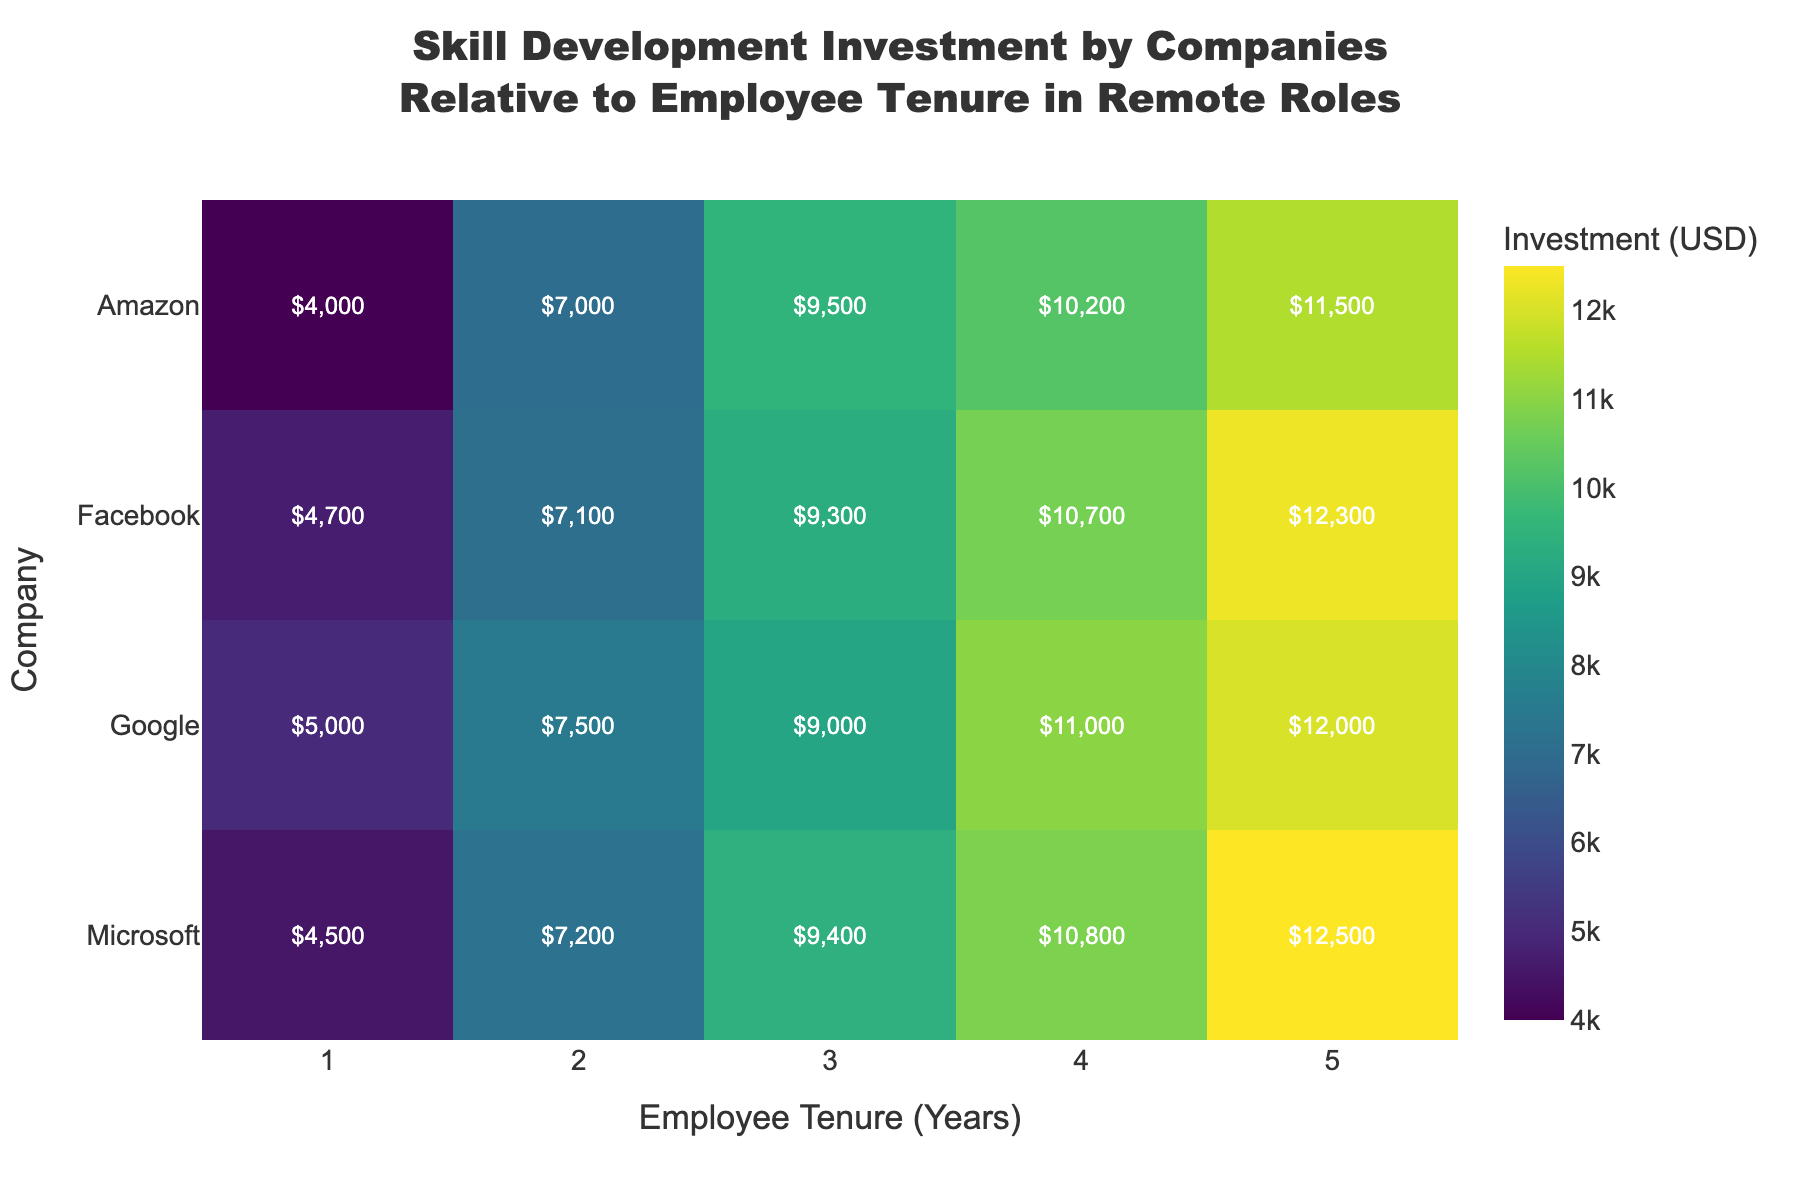What is the title of the heatmap? The title is displayed at the top center of the heatmap. It reads "Skill Development Investment by Companies Relative to Employee Tenure in Remote Roles".
Answer: "Skill Development Investment by Companies Relative to Employee Tenure in Remote Roles" Which company has the highest skill development investment for employees with 5 years of tenure? From the heatmap, the investment amounts for employees with 5 years of tenure are shown for each company. Microsoft has the highest amount at $12,500.
Answer: Microsoft What is the color scale used in the heatmap? The color scale is described as a 'Viridis' palette, which transitions from dark purple to bright yellow-green as the investment amount increases.
Answer: 'Viridis' How does the investment trend for employees at Amazon compare from 1 to 5 years of tenure? The heatmap shows the investment amounts for Amazon at 1 to 5 years: 1 year ($4,000), 2 years ($7,000), 3 years ($9,500), 4 years ($10,200), 5 years ($11,500). The trend is an increasing investment amount with increasing tenure.
Answer: increasing Which company has the lowest investment for employees with 2 years of tenure? The heatmap cells showing investment amount for employees with 2 years of tenure reveal that Facebook has the lowest investment at $7,100.
Answer: Facebook What is the average investment made by Google across all tenure levels? From the heatmap, the investment values for Google are: 1 year ($5,000), 2 years ($7,500), 3 years ($9,000), 4 years ($11,000), 5 years ($12,000). The average is calculated as (5000 + 7500 + 9000 + 11000 + 12000) / 5 = $8,900.
Answer: $8,900 Is there a company that consistently increases its investment year-by-year without any decrease? The heatmap shows investment values for each tenure year. Google, Amazon, Microsoft, and Facebook each show a consistent year-by-year increase with no decreases in their investment amounts.
Answer: Yes Comparing Microsoft and Facebook, which one has a higher investment for employees with 4 years of tenure? The heatmap shows that Microsoft has an investment of $10,800 for 4 years of tenure and Facebook has $10,700 for the same tenure. Microsoft has the higher investment.
Answer: Microsoft What is the total skill development investment made by all companies for employees with 3 years of tenure? The heatmap shows the investments for 3 years of tenure: Google ($9,000), Amazon ($9,500), Microsoft ($9,400), Facebook ($9,300). Summing these up gives 9000 + 9500 + 9400 + 9300 = $37,200.
Answer: $37,200 